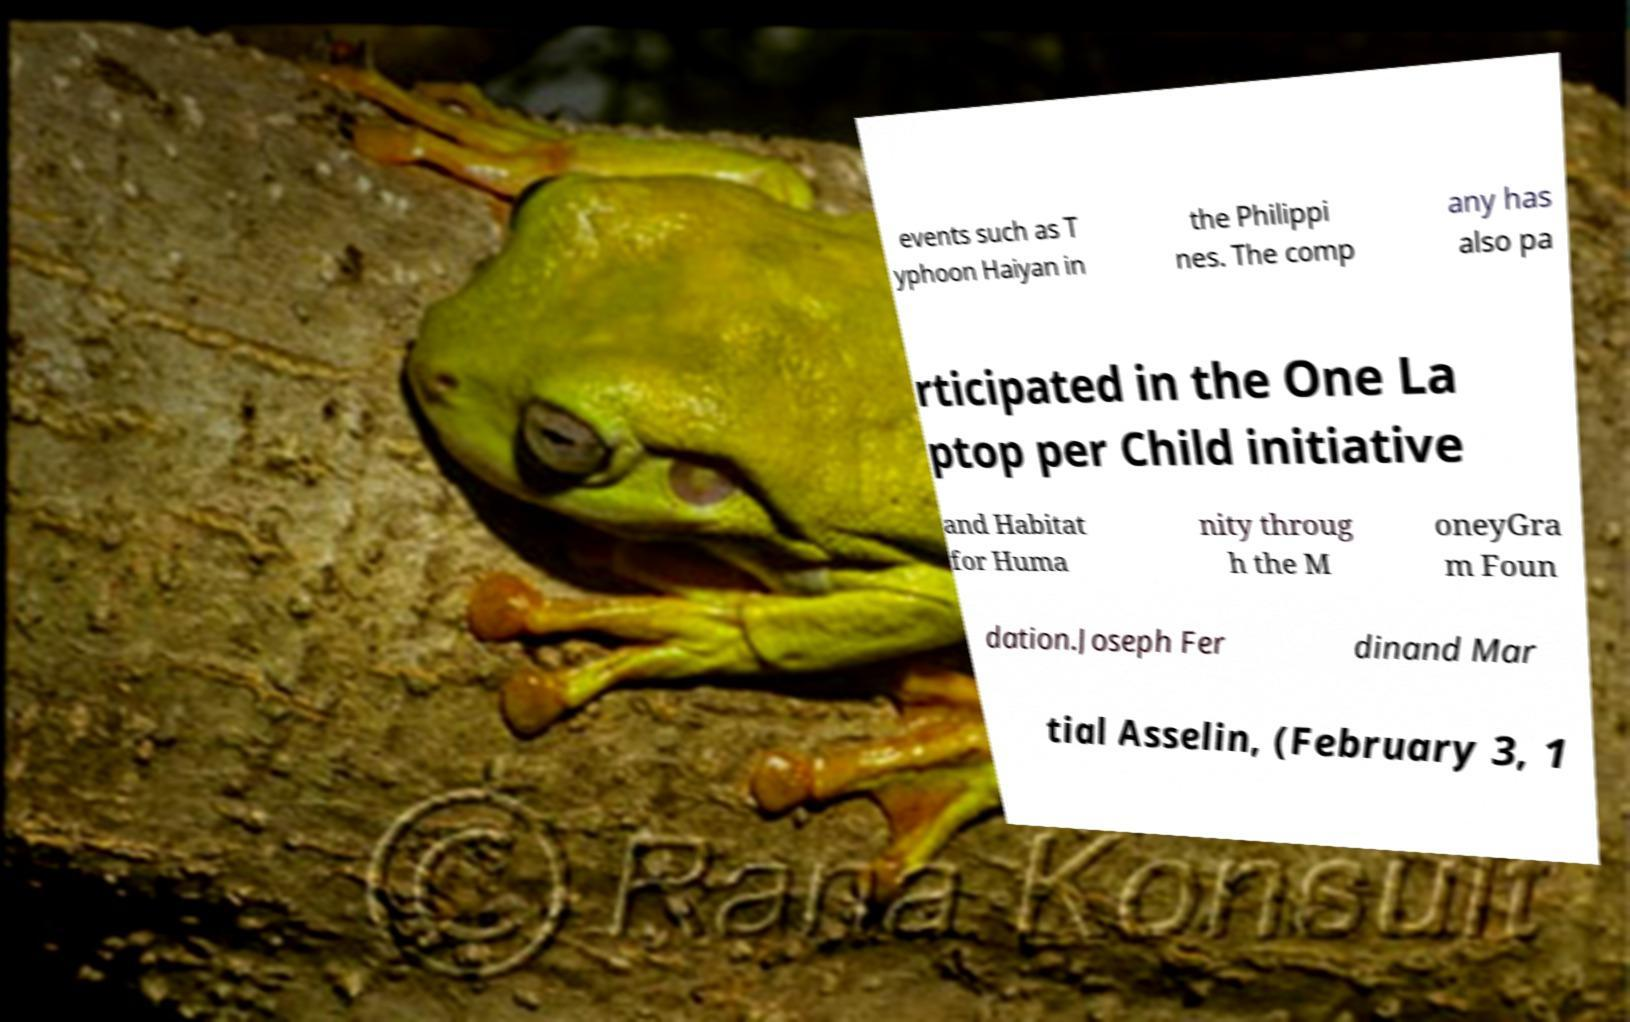Please read and relay the text visible in this image. What does it say? events such as T yphoon Haiyan in the Philippi nes. The comp any has also pa rticipated in the One La ptop per Child initiative and Habitat for Huma nity throug h the M oneyGra m Foun dation.Joseph Fer dinand Mar tial Asselin, (February 3, 1 